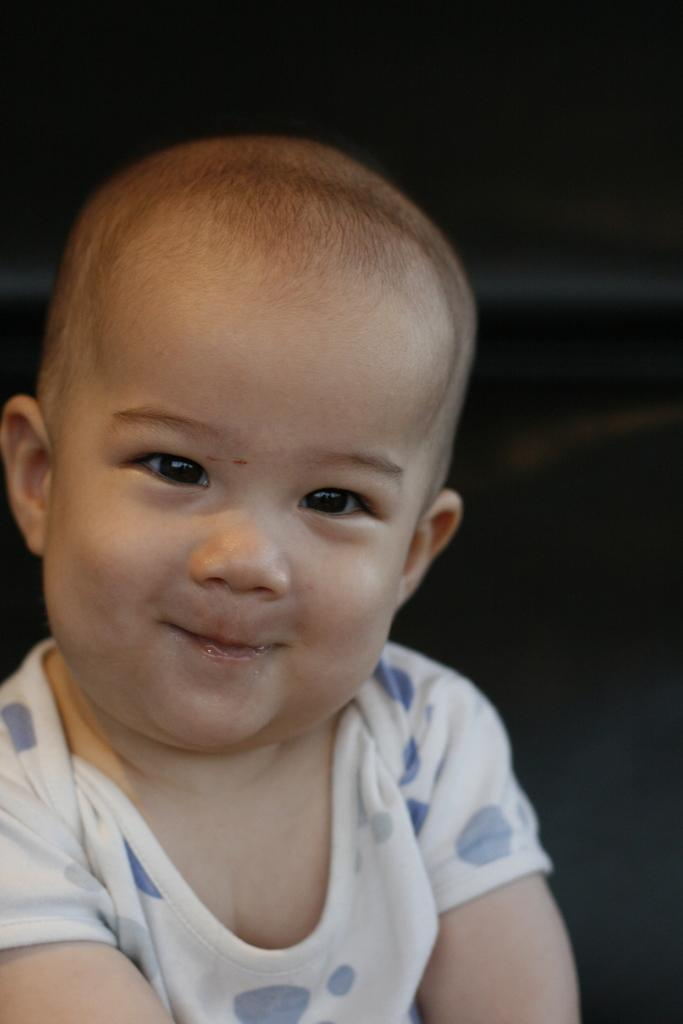What is the main subject of the image? The main subject of the image is a baby. What type of jeans is the baby wearing in the image? The image does not provide information about the baby's clothing, so it cannot be determined if the baby is wearing jeans or any other type of clothing. 